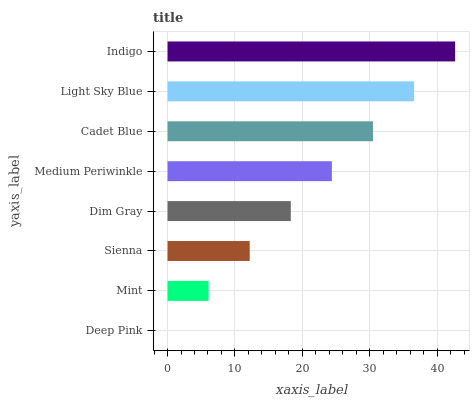Is Deep Pink the minimum?
Answer yes or no. Yes. Is Indigo the maximum?
Answer yes or no. Yes. Is Mint the minimum?
Answer yes or no. No. Is Mint the maximum?
Answer yes or no. No. Is Mint greater than Deep Pink?
Answer yes or no. Yes. Is Deep Pink less than Mint?
Answer yes or no. Yes. Is Deep Pink greater than Mint?
Answer yes or no. No. Is Mint less than Deep Pink?
Answer yes or no. No. Is Medium Periwinkle the high median?
Answer yes or no. Yes. Is Dim Gray the low median?
Answer yes or no. Yes. Is Deep Pink the high median?
Answer yes or no. No. Is Mint the low median?
Answer yes or no. No. 